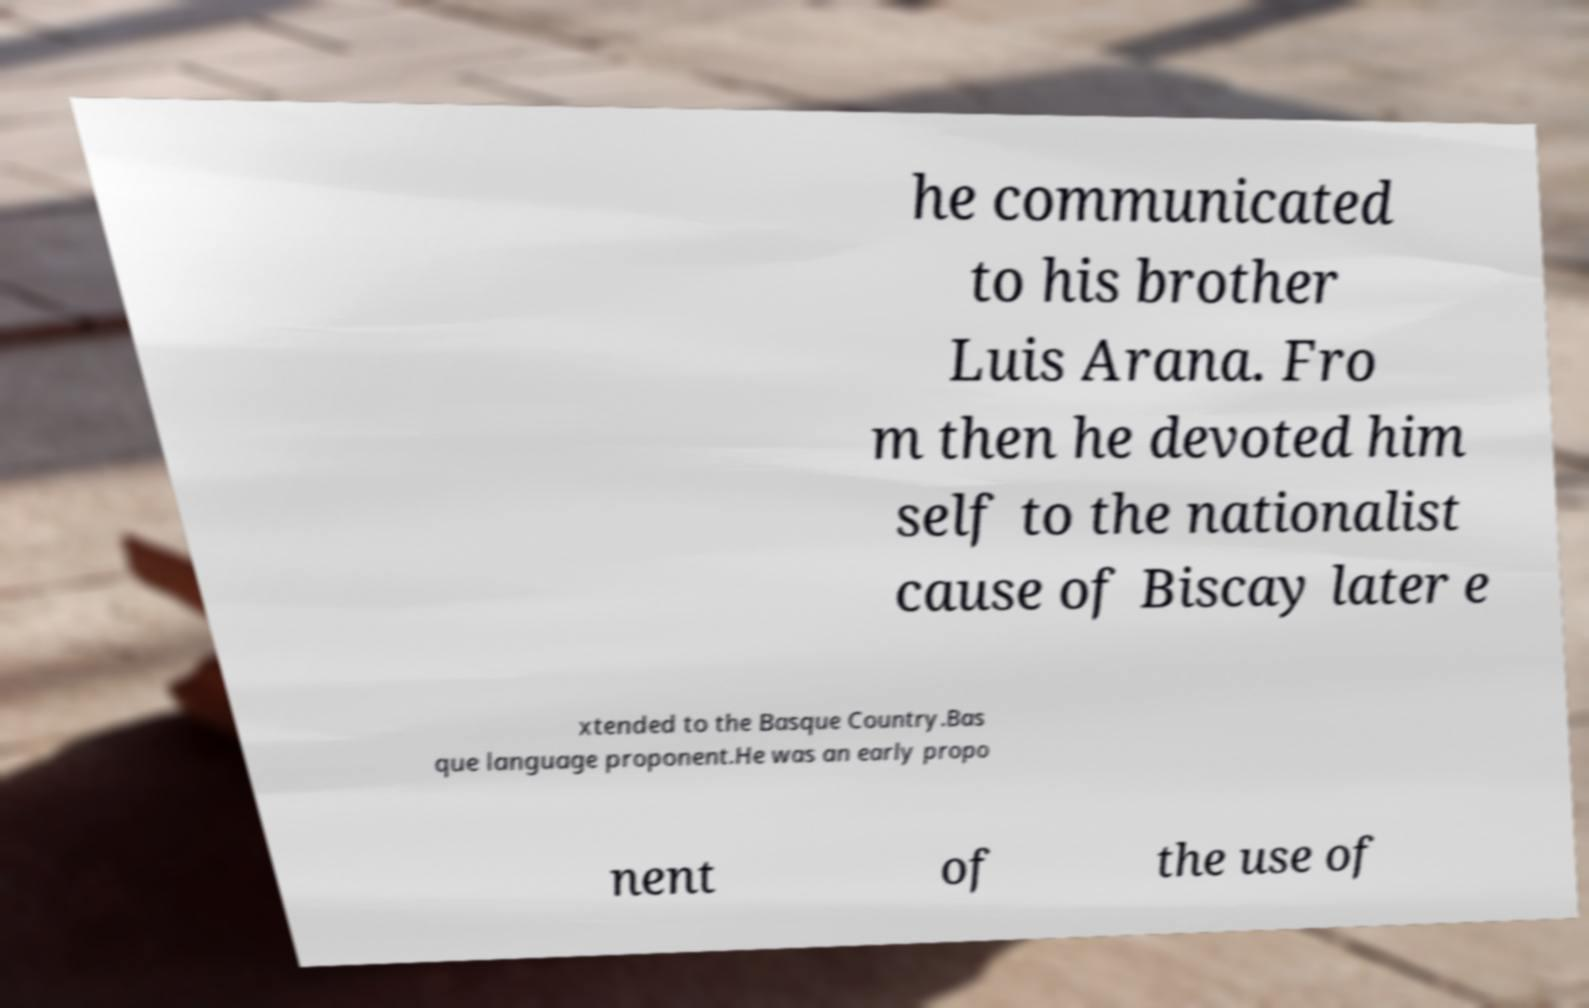What messages or text are displayed in this image? I need them in a readable, typed format. he communicated to his brother Luis Arana. Fro m then he devoted him self to the nationalist cause of Biscay later e xtended to the Basque Country.Bas que language proponent.He was an early propo nent of the use of 